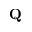<formula> <loc_0><loc_0><loc_500><loc_500>Q</formula> 